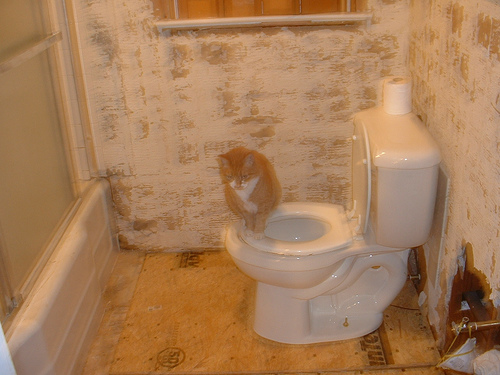Read all the text in this image. SD 